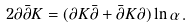<formula> <loc_0><loc_0><loc_500><loc_500>2 \partial \bar { \partial } K = ( \partial K \bar { \partial } + \bar { \partial } K \partial ) \ln \alpha \, .</formula> 